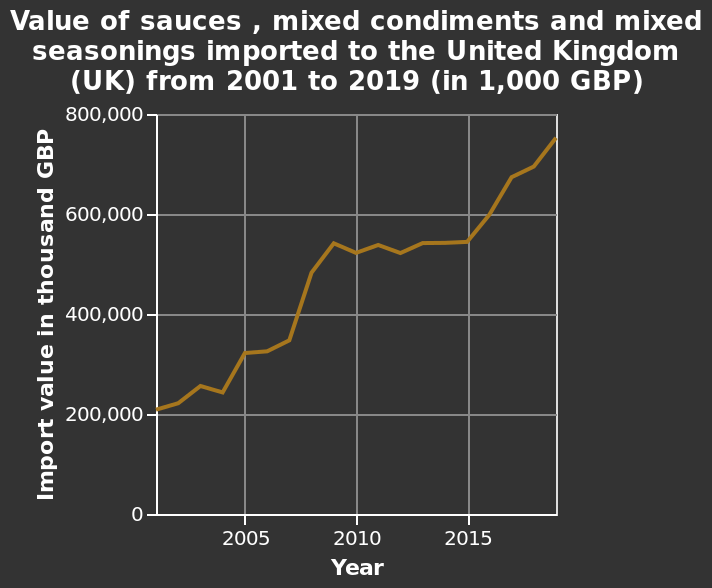<image>
What is the relationship between import costs and the increase in sauces, condiments, and seasonings?  The increase in import costs for sauces, condiments, and seasonings is linear. What is the range of import value shown on the chart? The range of import value shown on the chart is from 0 to 800,000 thousand GBP. Are people importing fewer sauces, condiments, and seasonings? No, people are importing more sauces, condiments, and seasonings. 